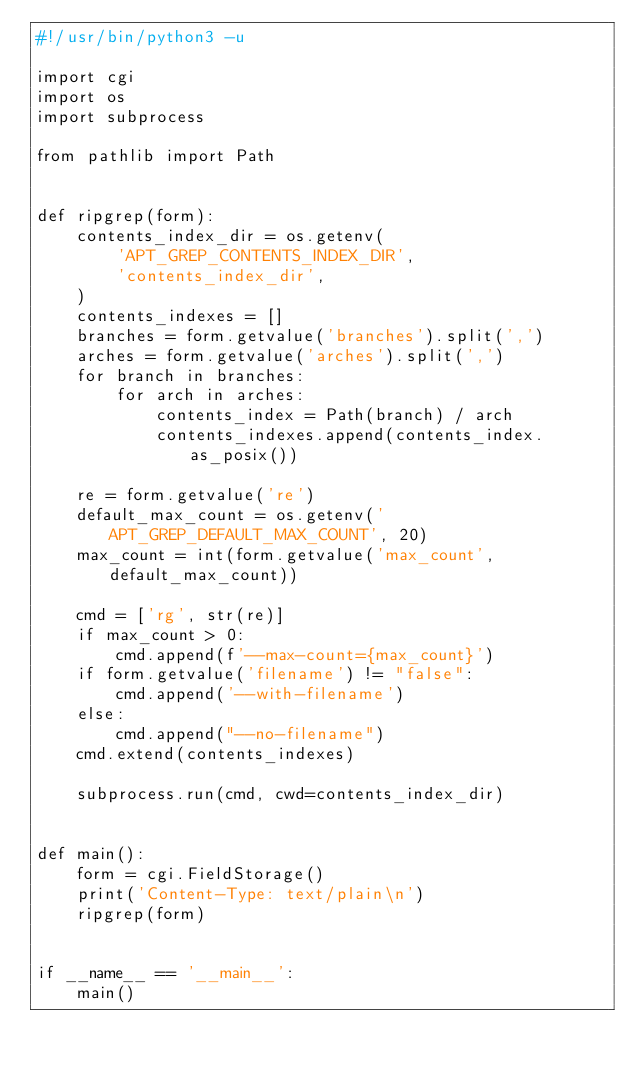<code> <loc_0><loc_0><loc_500><loc_500><_Python_>#!/usr/bin/python3 -u

import cgi
import os
import subprocess

from pathlib import Path


def ripgrep(form):
    contents_index_dir = os.getenv(
        'APT_GREP_CONTENTS_INDEX_DIR',
        'contents_index_dir',
    )
    contents_indexes = []
    branches = form.getvalue('branches').split(',')
    arches = form.getvalue('arches').split(',')
    for branch in branches:
        for arch in arches:
            contents_index = Path(branch) / arch
            contents_indexes.append(contents_index.as_posix())

    re = form.getvalue('re')
    default_max_count = os.getenv('APT_GREP_DEFAULT_MAX_COUNT', 20)
    max_count = int(form.getvalue('max_count', default_max_count))

    cmd = ['rg', str(re)]
    if max_count > 0:
        cmd.append(f'--max-count={max_count}')
    if form.getvalue('filename') != "false":
        cmd.append('--with-filename')
    else:
        cmd.append("--no-filename")
    cmd.extend(contents_indexes)

    subprocess.run(cmd, cwd=contents_index_dir)


def main():
    form = cgi.FieldStorage()
    print('Content-Type: text/plain\n')
    ripgrep(form)


if __name__ == '__main__':
    main()
</code> 